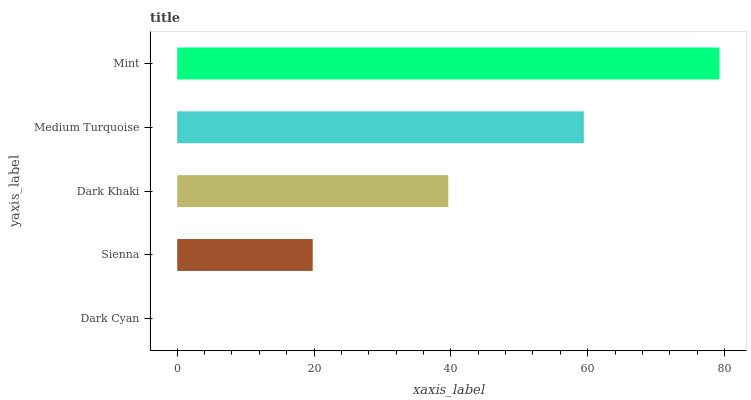Is Dark Cyan the minimum?
Answer yes or no. Yes. Is Mint the maximum?
Answer yes or no. Yes. Is Sienna the minimum?
Answer yes or no. No. Is Sienna the maximum?
Answer yes or no. No. Is Sienna greater than Dark Cyan?
Answer yes or no. Yes. Is Dark Cyan less than Sienna?
Answer yes or no. Yes. Is Dark Cyan greater than Sienna?
Answer yes or no. No. Is Sienna less than Dark Cyan?
Answer yes or no. No. Is Dark Khaki the high median?
Answer yes or no. Yes. Is Dark Khaki the low median?
Answer yes or no. Yes. Is Dark Cyan the high median?
Answer yes or no. No. Is Mint the low median?
Answer yes or no. No. 